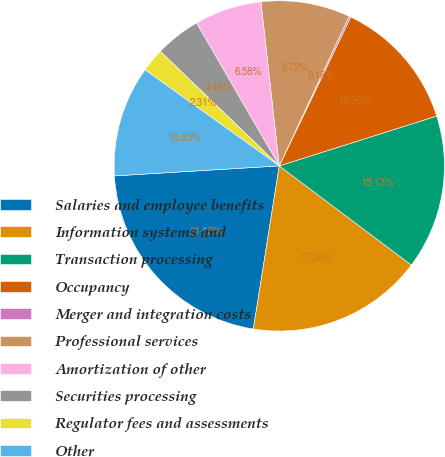<chart> <loc_0><loc_0><loc_500><loc_500><pie_chart><fcel>Salaries and employee benefits<fcel>Information systems and<fcel>Transaction processing<fcel>Occupancy<fcel>Merger and integration costs<fcel>Professional services<fcel>Amortization of other<fcel>Securities processing<fcel>Regulator fees and assessments<fcel>Other<nl><fcel>21.53%<fcel>17.26%<fcel>15.13%<fcel>12.99%<fcel>0.18%<fcel>8.72%<fcel>6.58%<fcel>4.45%<fcel>2.31%<fcel>10.85%<nl></chart> 